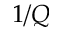Convert formula to latex. <formula><loc_0><loc_0><loc_500><loc_500>1 / Q</formula> 